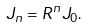Convert formula to latex. <formula><loc_0><loc_0><loc_500><loc_500>J _ { n } = R ^ { n } J _ { 0 } .</formula> 